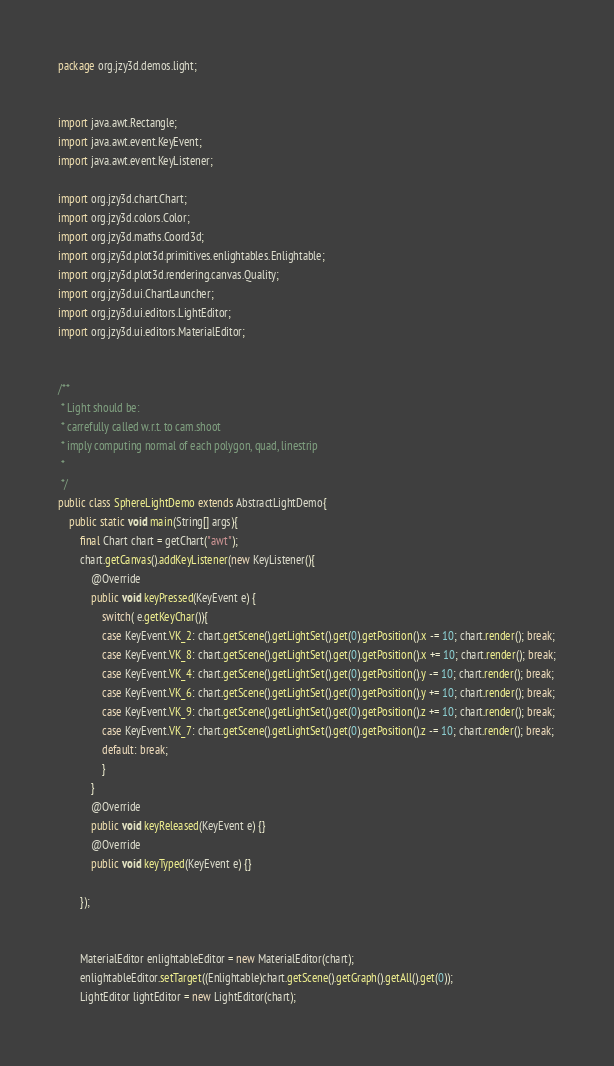<code> <loc_0><loc_0><loc_500><loc_500><_Java_>package org.jzy3d.demos.light;


import java.awt.Rectangle;
import java.awt.event.KeyEvent;
import java.awt.event.KeyListener;

import org.jzy3d.chart.Chart;
import org.jzy3d.colors.Color;
import org.jzy3d.maths.Coord3d;
import org.jzy3d.plot3d.primitives.enlightables.Enlightable;
import org.jzy3d.plot3d.rendering.canvas.Quality;
import org.jzy3d.ui.ChartLauncher;
import org.jzy3d.ui.editors.LightEditor;
import org.jzy3d.ui.editors.MaterialEditor;


/**
 * Light should be:
 * carrefully called w.r.t. to cam.shoot
 * imply computing normal of each polygon, quad, linestrip
 * 
 */
public class SphereLightDemo extends AbstractLightDemo{
	public static void main(String[] args){
		final Chart chart = getChart("awt");
		chart.getCanvas().addKeyListener(new KeyListener(){
			@Override
			public void keyPressed(KeyEvent e) {
				switch( e.getKeyChar()){
				case KeyEvent.VK_2: chart.getScene().getLightSet().get(0).getPosition().x -= 10; chart.render(); break;
				case KeyEvent.VK_8: chart.getScene().getLightSet().get(0).getPosition().x += 10; chart.render(); break;
				case KeyEvent.VK_4: chart.getScene().getLightSet().get(0).getPosition().y -= 10; chart.render(); break;
				case KeyEvent.VK_6: chart.getScene().getLightSet().get(0).getPosition().y += 10; chart.render(); break;
				case KeyEvent.VK_9: chart.getScene().getLightSet().get(0).getPosition().z += 10; chart.render(); break;
				case KeyEvent.VK_7: chart.getScene().getLightSet().get(0).getPosition().z -= 10; chart.render(); break;
				default: break;
		        }
			}
			@Override
			public void keyReleased(KeyEvent e) {}
			@Override
			public void keyTyped(KeyEvent e) {}
			
		});
		
		
		MaterialEditor enlightableEditor = new MaterialEditor(chart);
		enlightableEditor.setTarget((Enlightable)chart.getScene().getGraph().getAll().get(0));
		LightEditor lightEditor = new LightEditor(chart);</code> 